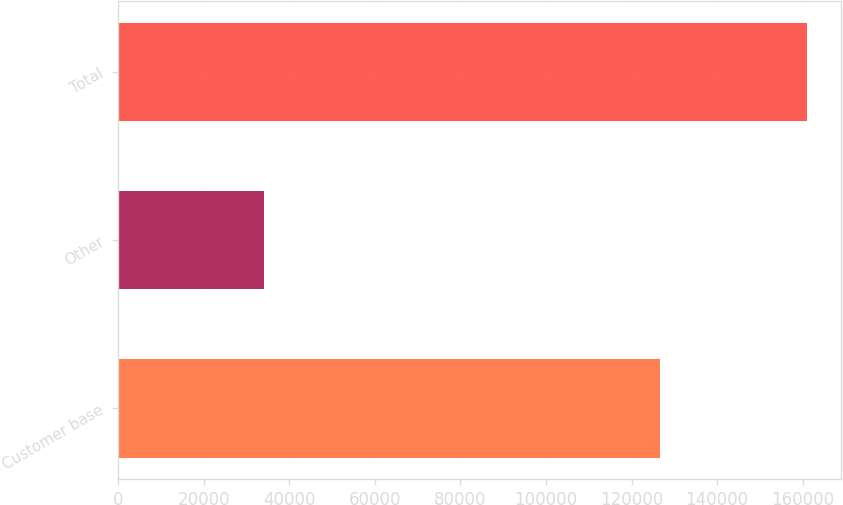Convert chart. <chart><loc_0><loc_0><loc_500><loc_500><bar_chart><fcel>Customer base<fcel>Other<fcel>Total<nl><fcel>126749<fcel>34186<fcel>160935<nl></chart> 